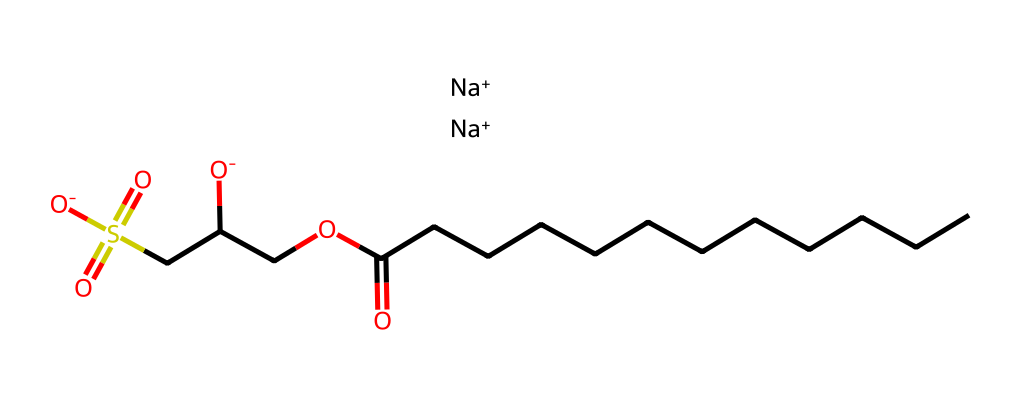What is the total number of carbon atoms in sodium cocoyl isethionate? The SMILES representation shows a long carbon chain starting with "CCCCCCCCCCCC" which indicates 12 carbon atoms in that chain. In addition, the remainder of the structure has 2 more carbon atoms from "CC" in the isethionate part. Thus, the total count is 14.
Answer: 14 How many oxygen atoms are present in the chemical structure? In the SMILES, "O" appears four times indicating there are four oxygen atoms in the structure: one from the carboxylic acid group (CCCCCCCCCCCC(=O)), two from the isethionate group (OCC(CS(=O)(=O)[O-])[O-]), and one is connected to sodium.
Answer: 4 What type of surfactant is sodium cocoyl isethionate classified as? The presence of a sulfate group and the overall structure indicates this is a mild anionic surfactant. Anionic surfactants are characterized by having a negative charge, which is seen in the isethionate part of the molecule.
Answer: anionic How many sodium ions are in the structure? The notation "[Na+].[Na+]" indicates there are two sodium ions present in the structure attached to the anionic surfactant part, suggesting their role in balancing the charge.
Answer: 2 What functional groups are present in sodium cocoyl isethionate? Analyzing the structure, there are several functional groups: a carboxylic acid (from CCCCCCCCCCCCC(=O)O), a sulfonic acid (from CS(=O)(=O)[O-]), and an ether type linkage (OCC). Thus, these functional groups contribute to its surfactant properties.
Answer: carboxylic acid, sulfonic acid, ether What is the significance of the long carbon chain found in sodium cocoyl isethionate? The long carbon chain in surfactants like sodium cocoyl isethionate contributes to its ability to solubilize oils and enhance the cleansing action. Longer chains improve the lipophilicity of the molecule, making it effective in emulsifying oils in cleansing products.
Answer: enhances cleansing action 